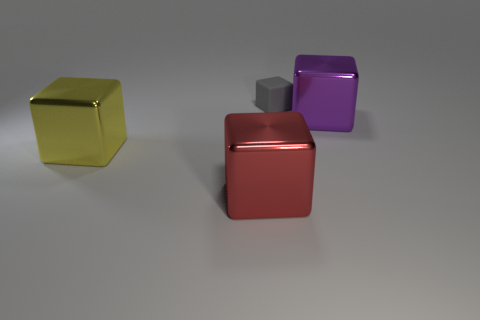Subtract all cyan blocks. Subtract all blue cylinders. How many blocks are left? 4 Add 1 big yellow matte things. How many objects exist? 5 Add 1 big red shiny blocks. How many big red shiny blocks are left? 2 Add 3 big green objects. How many big green objects exist? 3 Subtract 0 red cylinders. How many objects are left? 4 Subtract all gray matte objects. Subtract all small gray rubber cubes. How many objects are left? 2 